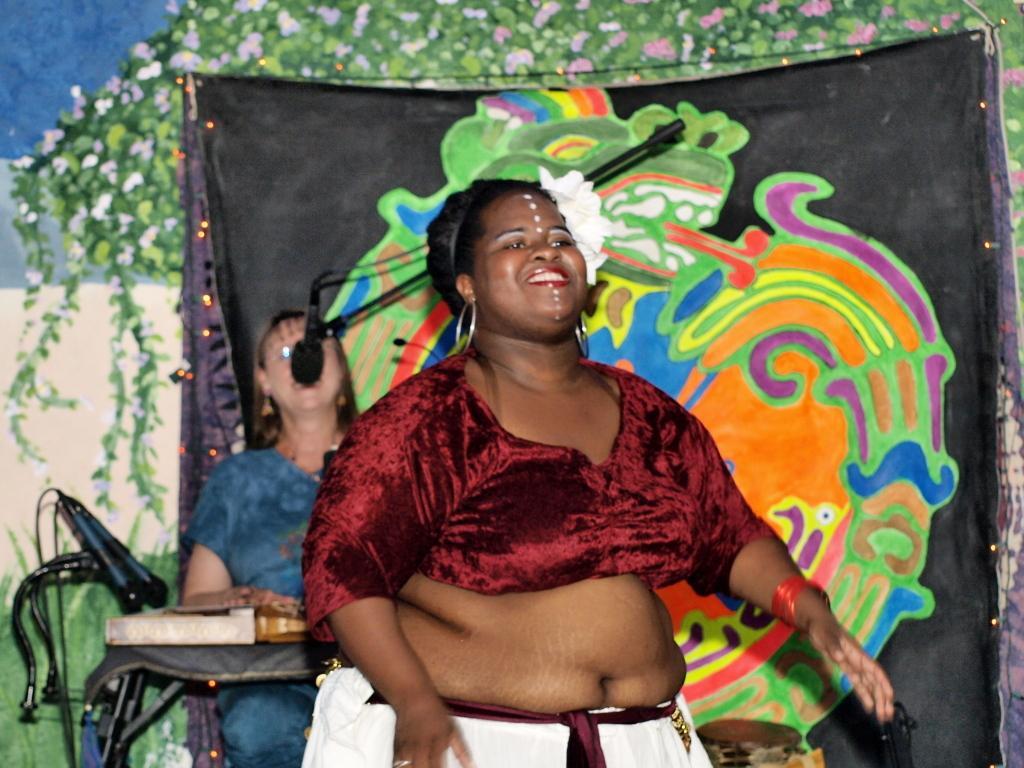Describe this image in one or two sentences. In this picture there is a woman standing and smiling, behind her we can see a woman sitting and playing a musical instrument and we can see microphones with stands. In the background of the image we can see banner, tree and flowers. 